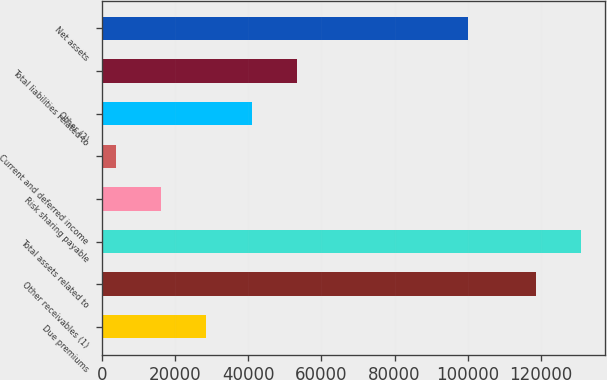Convert chart to OTSL. <chart><loc_0><loc_0><loc_500><loc_500><bar_chart><fcel>Due premiums<fcel>Other receivables (1)<fcel>Total assets related to<fcel>Risk sharing payable<fcel>Current and deferred income<fcel>Other (2)<fcel>Total liabilities related to<fcel>Net assets<nl><fcel>28562.4<fcel>118692<fcel>131063<fcel>16191.2<fcel>3820<fcel>40933.6<fcel>53304.8<fcel>100108<nl></chart> 